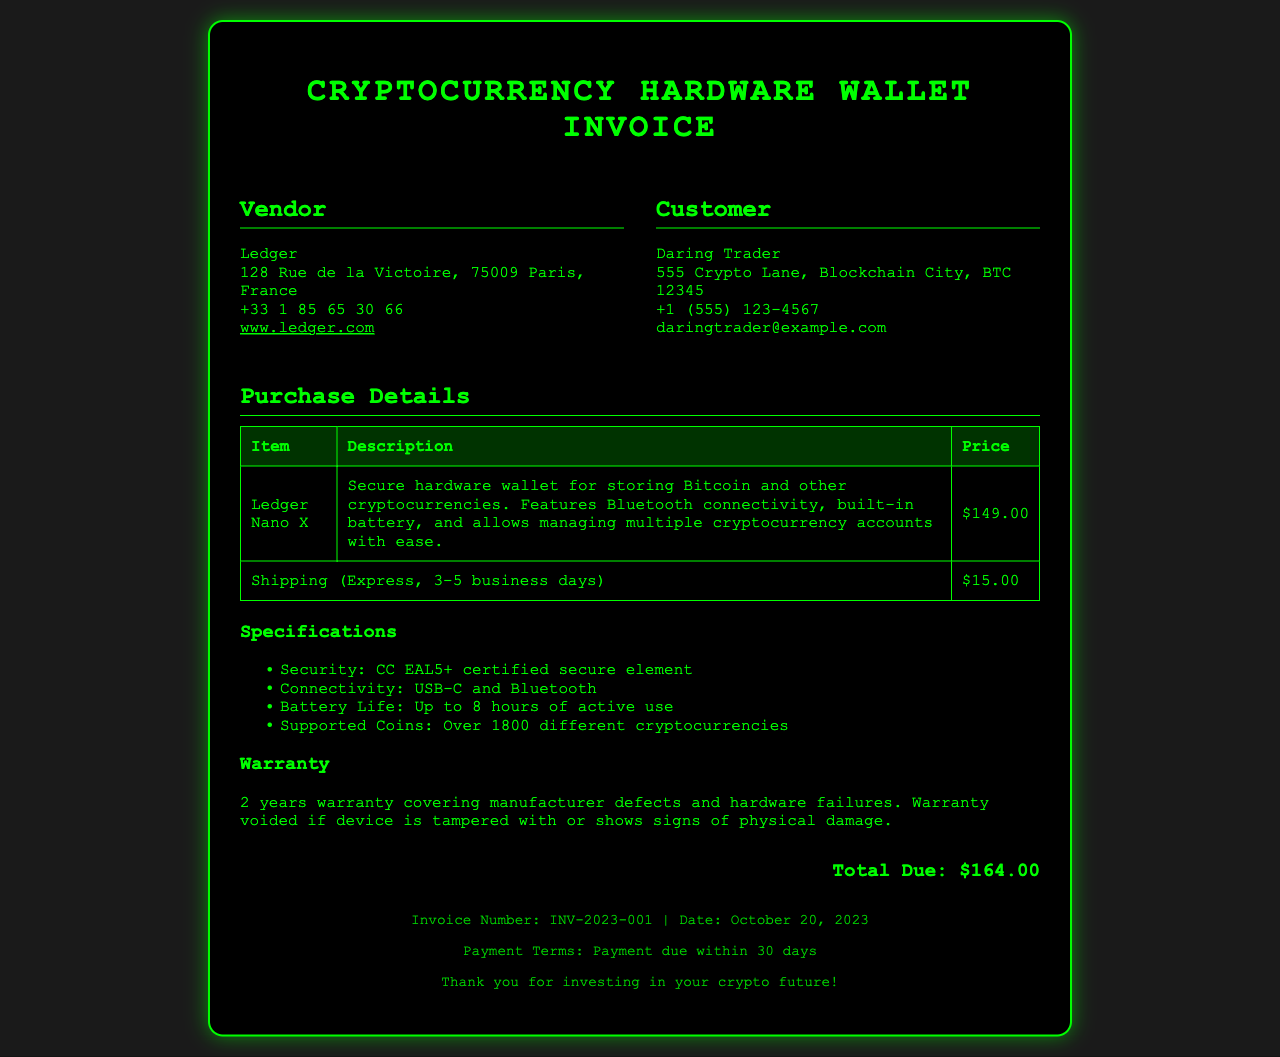what is the vendor name? The vendor name is listed in the document as Ledger.
Answer: Ledger what is the total due amount? The total due amount is stated clearly at the bottom of the invoice.
Answer: $164.00 what is the warranty period for the hardware wallet? The warranty period for the hardware wallet is mentioned in the warranty section.
Answer: 2 years what is the shipping cost? The shipping cost for the express service is noted in the purchase details table.
Answer: $15.00 how many cryptocurrencies does the hardware wallet support? The supported coins are mentioned in the specifications section of the document.
Answer: Over 1800 different cryptocurrencies what is the invoice number? The invoice number can be found in the footer section of the document.
Answer: INV-2023-001 what is the customer’s email address? The customer’s email address is provided in the customer section.
Answer: daringtrader@example.com what is the connectivity feature of the Ledger Nano X? The connectivity feature is indicated in the specifications section detailing connection options.
Answer: USB-C and Bluetooth what are the payment terms? The payment terms are stated in the footer section of the invoice document.
Answer: Payment due within 30 days what is the item being purchased? The item being purchased is clearly highlighted in the purchase details table.
Answer: Ledger Nano X 